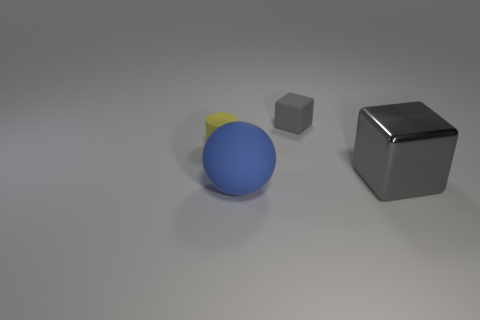Is there any other thing that is the same shape as the large rubber thing?
Offer a very short reply. No. What number of green things are big rubber spheres or cylinders?
Keep it short and to the point. 0. What number of gray metallic cubes are the same size as the yellow rubber thing?
Provide a succinct answer. 0. What number of objects are big brown rubber things or objects behind the metallic block?
Keep it short and to the point. 2. There is a thing that is in front of the shiny thing; does it have the same size as the rubber object that is behind the small cylinder?
Your answer should be very brief. No. What number of gray things have the same shape as the big blue object?
Your answer should be very brief. 0. The tiny gray object that is the same material as the tiny yellow cylinder is what shape?
Your answer should be very brief. Cube. The large object right of the rubber object that is in front of the gray block that is in front of the yellow rubber cylinder is made of what material?
Your answer should be compact. Metal. Is the size of the rubber ball the same as the gray object that is behind the yellow cylinder?
Your response must be concise. No. What is the material of the other object that is the same shape as the small gray rubber thing?
Provide a short and direct response. Metal. 